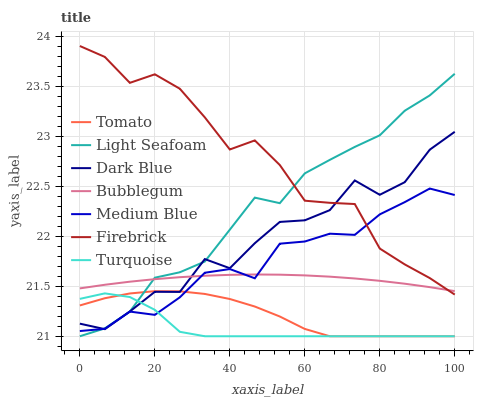Does Turquoise have the minimum area under the curve?
Answer yes or no. Yes. Does Firebrick have the maximum area under the curve?
Answer yes or no. Yes. Does Firebrick have the minimum area under the curve?
Answer yes or no. No. Does Turquoise have the maximum area under the curve?
Answer yes or no. No. Is Bubblegum the smoothest?
Answer yes or no. Yes. Is Dark Blue the roughest?
Answer yes or no. Yes. Is Turquoise the smoothest?
Answer yes or no. No. Is Turquoise the roughest?
Answer yes or no. No. Does Tomato have the lowest value?
Answer yes or no. Yes. Does Firebrick have the lowest value?
Answer yes or no. No. Does Firebrick have the highest value?
Answer yes or no. Yes. Does Turquoise have the highest value?
Answer yes or no. No. Is Turquoise less than Firebrick?
Answer yes or no. Yes. Is Bubblegum greater than Turquoise?
Answer yes or no. Yes. Does Medium Blue intersect Tomato?
Answer yes or no. Yes. Is Medium Blue less than Tomato?
Answer yes or no. No. Is Medium Blue greater than Tomato?
Answer yes or no. No. Does Turquoise intersect Firebrick?
Answer yes or no. No. 